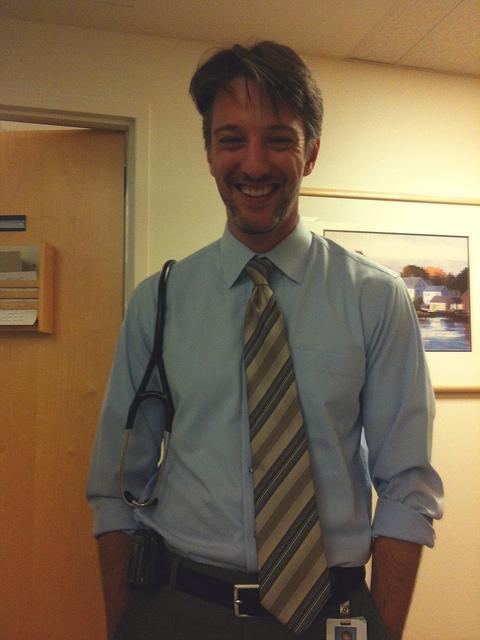How many televisions are in the picture?
Give a very brief answer. 0. How many ski poles are to the right of the skier?
Give a very brief answer. 0. 